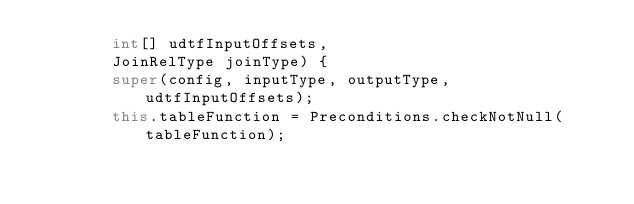<code> <loc_0><loc_0><loc_500><loc_500><_Java_>		int[] udtfInputOffsets,
		JoinRelType joinType) {
		super(config, inputType, outputType, udtfInputOffsets);
		this.tableFunction = Preconditions.checkNotNull(tableFunction);</code> 